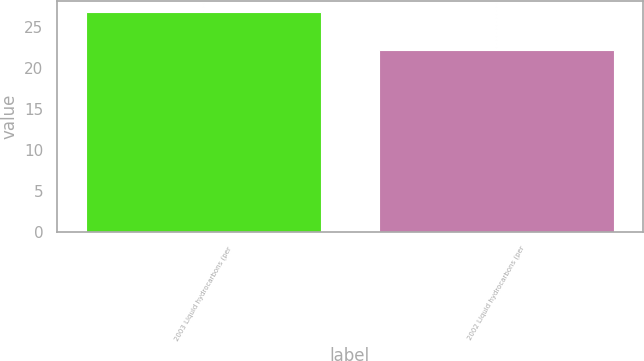<chart> <loc_0><loc_0><loc_500><loc_500><bar_chart><fcel>2003 Liquid hydrocarbons (per<fcel>2002 Liquid hydrocarbons (per<nl><fcel>26.92<fcel>22.18<nl></chart> 